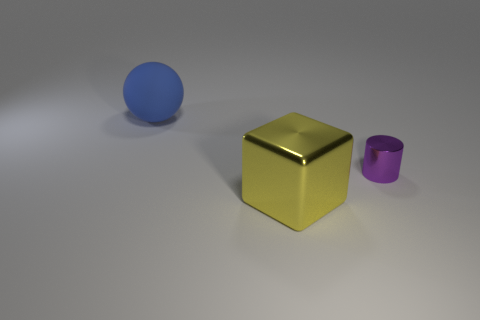What might be the significance of the golden cube being in the center? The golden cube's central position might suggest a place of importance or value, as gold often symbolizes wealth and prestige. Its position could also be purely aesthetic, providing a striking contrast in both color and shape between the blue sphere and purple cylinder. Without additional context, it's open to personal interpretation, perhaps stirring the observer to reflect on the cube's metaphorical value in the composition. 